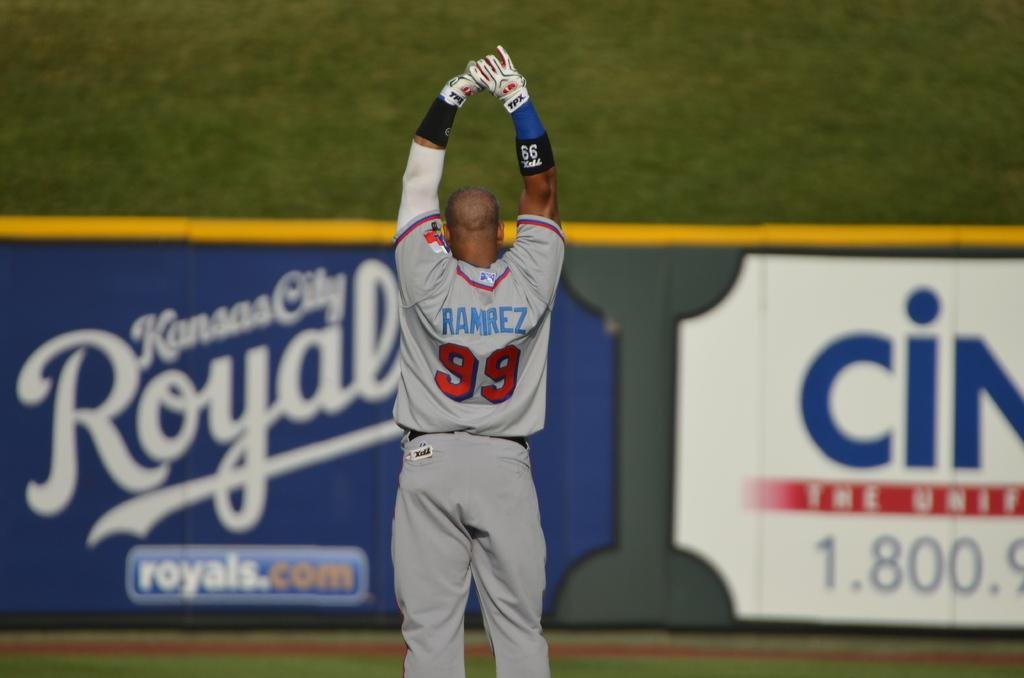<image>
Write a terse but informative summary of the picture. Baseball player stretching his arms and has a gray uniform with Ramirez on the back. 